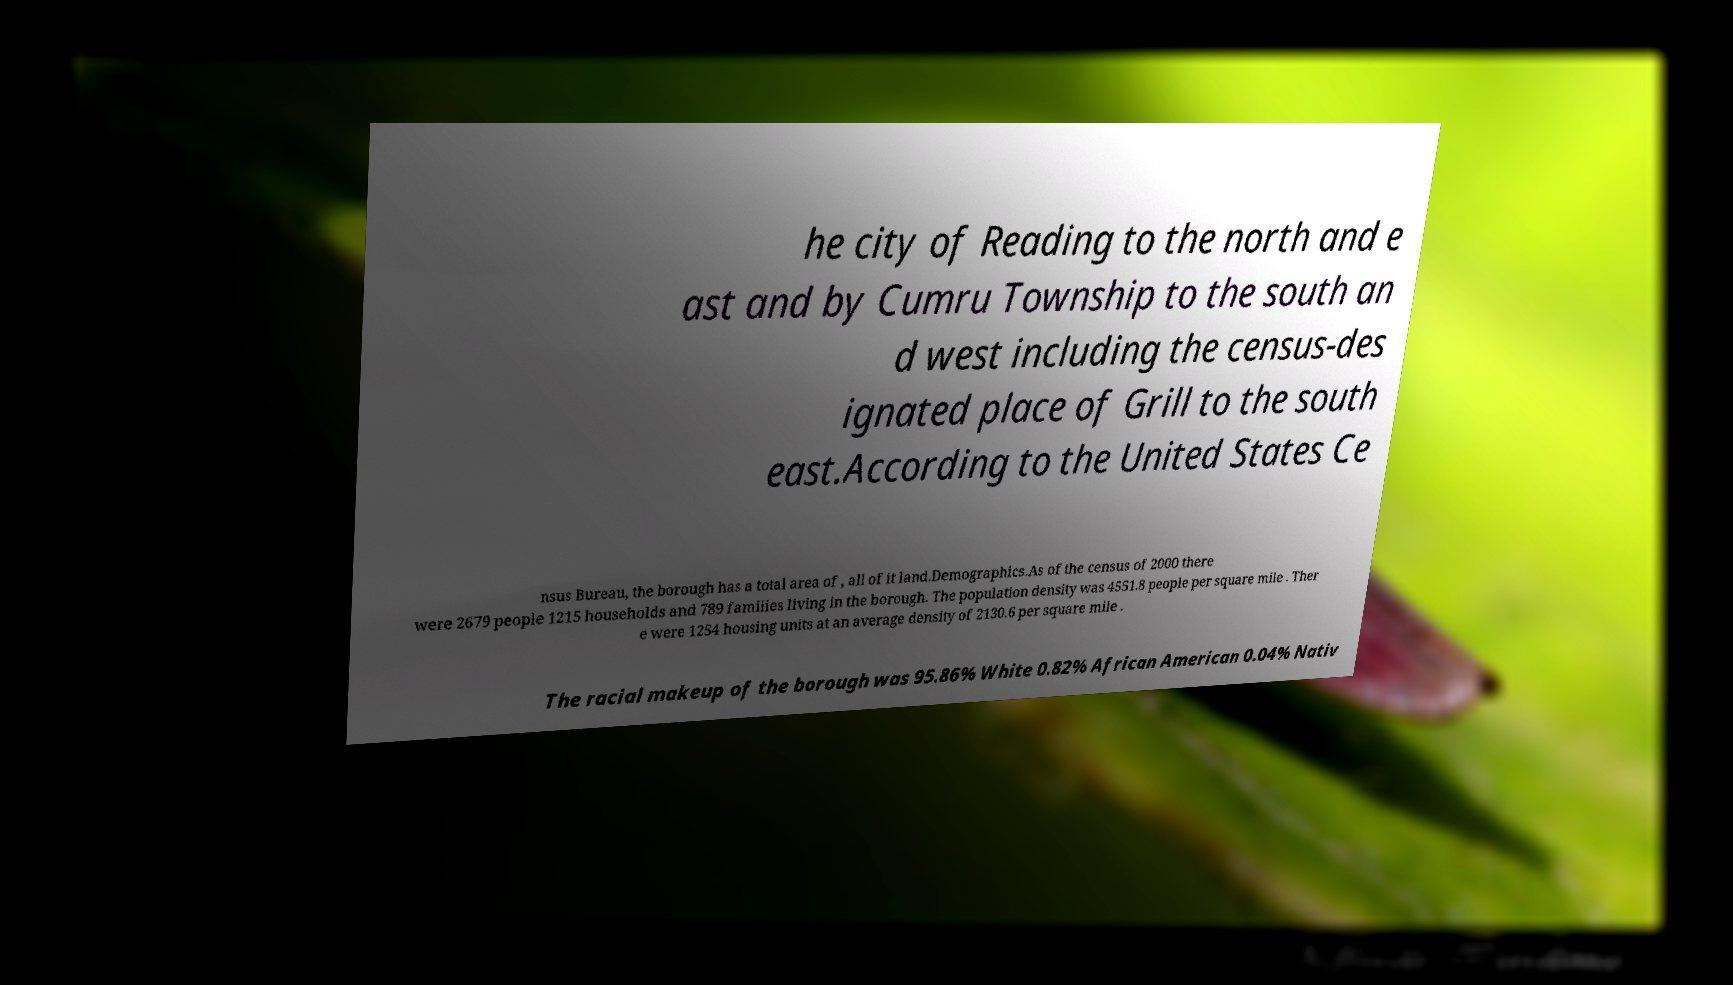Can you read and provide the text displayed in the image?This photo seems to have some interesting text. Can you extract and type it out for me? he city of Reading to the north and e ast and by Cumru Township to the south an d west including the census-des ignated place of Grill to the south east.According to the United States Ce nsus Bureau, the borough has a total area of , all of it land.Demographics.As of the census of 2000 there were 2679 people 1215 households and 789 families living in the borough. The population density was 4551.8 people per square mile . Ther e were 1254 housing units at an average density of 2130.6 per square mile . The racial makeup of the borough was 95.86% White 0.82% African American 0.04% Nativ 